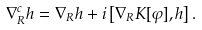Convert formula to latex. <formula><loc_0><loc_0><loc_500><loc_500>\nabla ^ { c } _ { R } { h } = \nabla _ { R } { h } + i \left [ \nabla _ { R } K [ \varphi ] , { h } \right ] .</formula> 